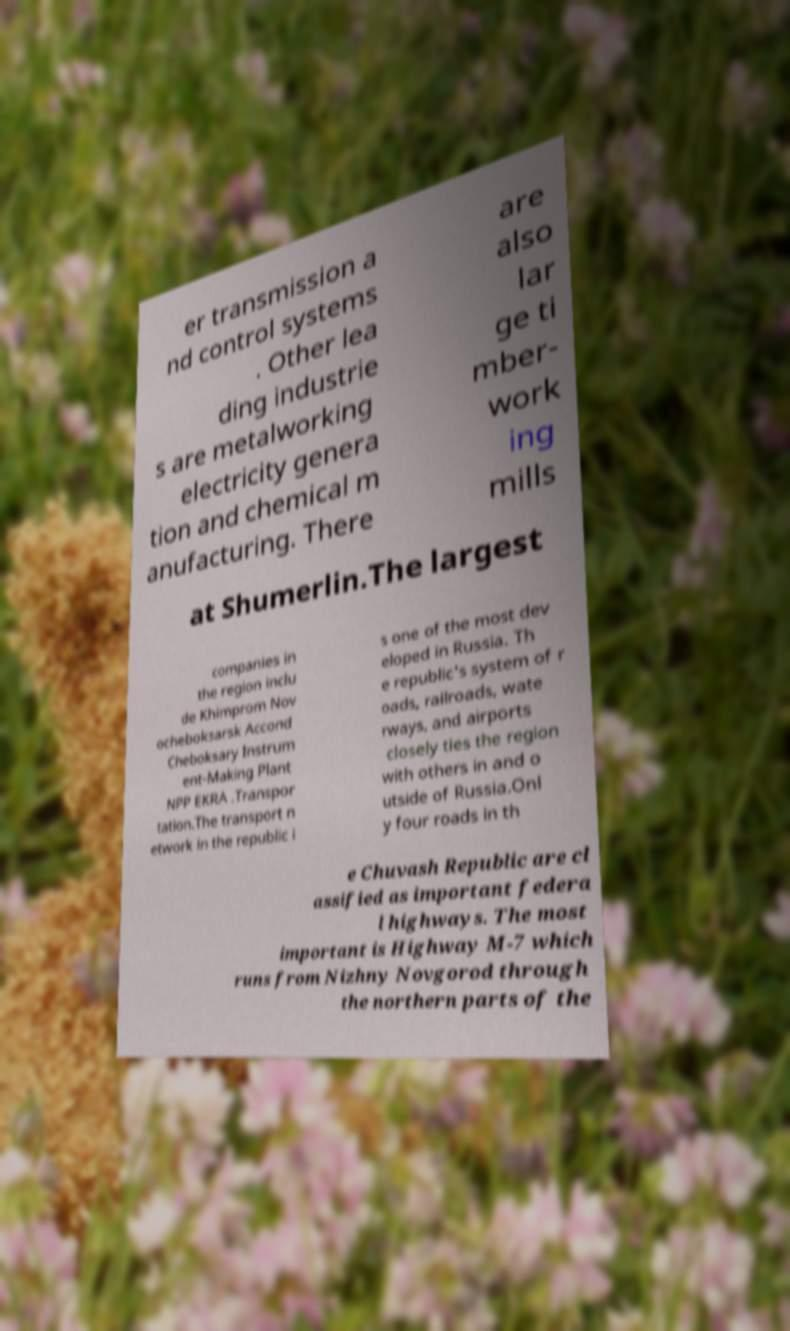For documentation purposes, I need the text within this image transcribed. Could you provide that? er transmission a nd control systems . Other lea ding industrie s are metalworking electricity genera tion and chemical m anufacturing. There are also lar ge ti mber- work ing mills at Shumerlin.The largest companies in the region inclu de Khimprom Nov ocheboksarsk Accond Cheboksary Instrum ent-Making Plant NPP EKRA .Transpor tation.The transport n etwork in the republic i s one of the most dev eloped in Russia. Th e republic's system of r oads, railroads, wate rways, and airports closely ties the region with others in and o utside of Russia.Onl y four roads in th e Chuvash Republic are cl assified as important federa l highways. The most important is Highway M-7 which runs from Nizhny Novgorod through the northern parts of the 